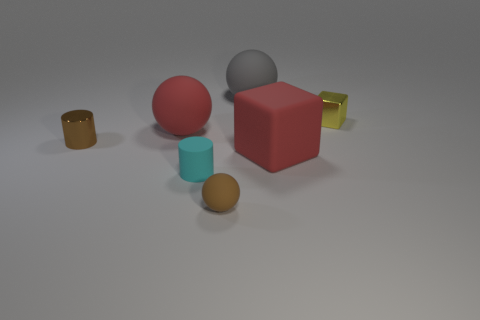Add 1 large yellow metallic things. How many objects exist? 8 Subtract all balls. How many objects are left? 4 Subtract all brown shiny cubes. Subtract all tiny brown metallic objects. How many objects are left? 6 Add 1 tiny matte cylinders. How many tiny matte cylinders are left? 2 Add 3 gray metal balls. How many gray metal balls exist? 3 Subtract 0 blue blocks. How many objects are left? 7 